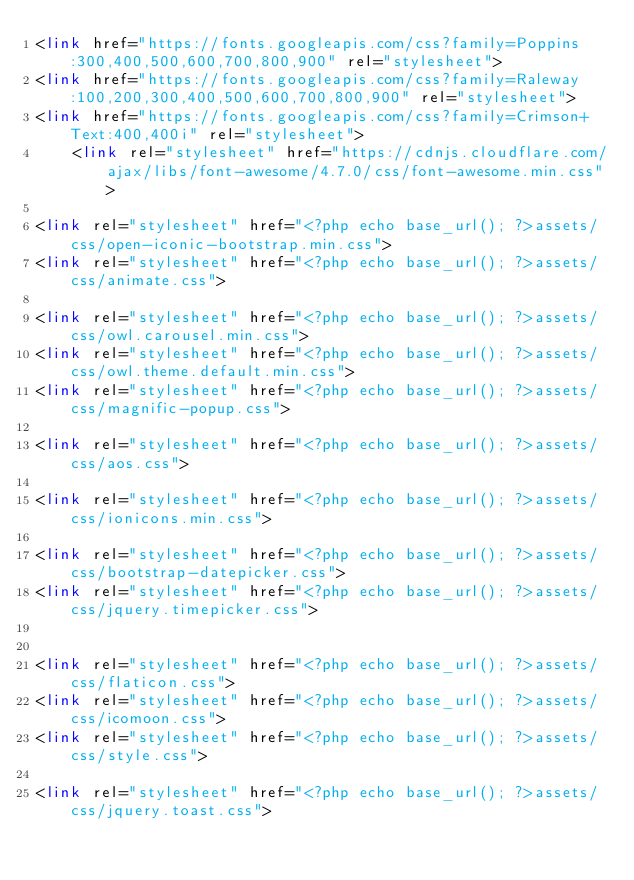Convert code to text. <code><loc_0><loc_0><loc_500><loc_500><_PHP_><link href="https://fonts.googleapis.com/css?family=Poppins:300,400,500,600,700,800,900" rel="stylesheet">
<link href="https://fonts.googleapis.com/css?family=Raleway:100,200,300,400,500,600,700,800,900" rel="stylesheet">
<link href="https://fonts.googleapis.com/css?family=Crimson+Text:400,400i" rel="stylesheet">
    <link rel="stylesheet" href="https://cdnjs.cloudflare.com/ajax/libs/font-awesome/4.7.0/css/font-awesome.min.css">

<link rel="stylesheet" href="<?php echo base_url(); ?>assets/css/open-iconic-bootstrap.min.css">
<link rel="stylesheet" href="<?php echo base_url(); ?>assets/css/animate.css">

<link rel="stylesheet" href="<?php echo base_url(); ?>assets/css/owl.carousel.min.css">
<link rel="stylesheet" href="<?php echo base_url(); ?>assets/css/owl.theme.default.min.css">
<link rel="stylesheet" href="<?php echo base_url(); ?>assets/css/magnific-popup.css">

<link rel="stylesheet" href="<?php echo base_url(); ?>assets/css/aos.css">

<link rel="stylesheet" href="<?php echo base_url(); ?>assets/css/ionicons.min.css">

<link rel="stylesheet" href="<?php echo base_url(); ?>assets/css/bootstrap-datepicker.css">
<link rel="stylesheet" href="<?php echo base_url(); ?>assets/css/jquery.timepicker.css">


<link rel="stylesheet" href="<?php echo base_url(); ?>assets/css/flaticon.css">
<link rel="stylesheet" href="<?php echo base_url(); ?>assets/css/icomoon.css">
<link rel="stylesheet" href="<?php echo base_url(); ?>assets/css/style.css">

<link rel="stylesheet" href="<?php echo base_url(); ?>assets/css/jquery.toast.css">

</code> 